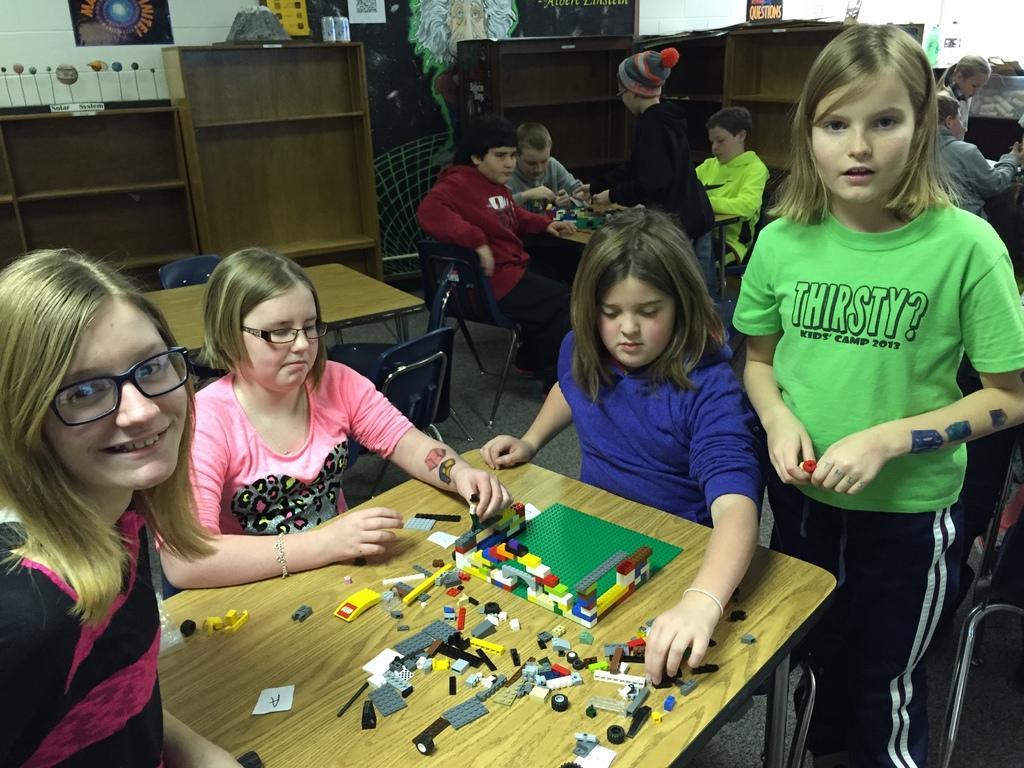Can you describe this image briefly? Here we can see a four girls playing with toys. This toys are kept on a table. In the background we can see a three boys who are also playing with toys. 